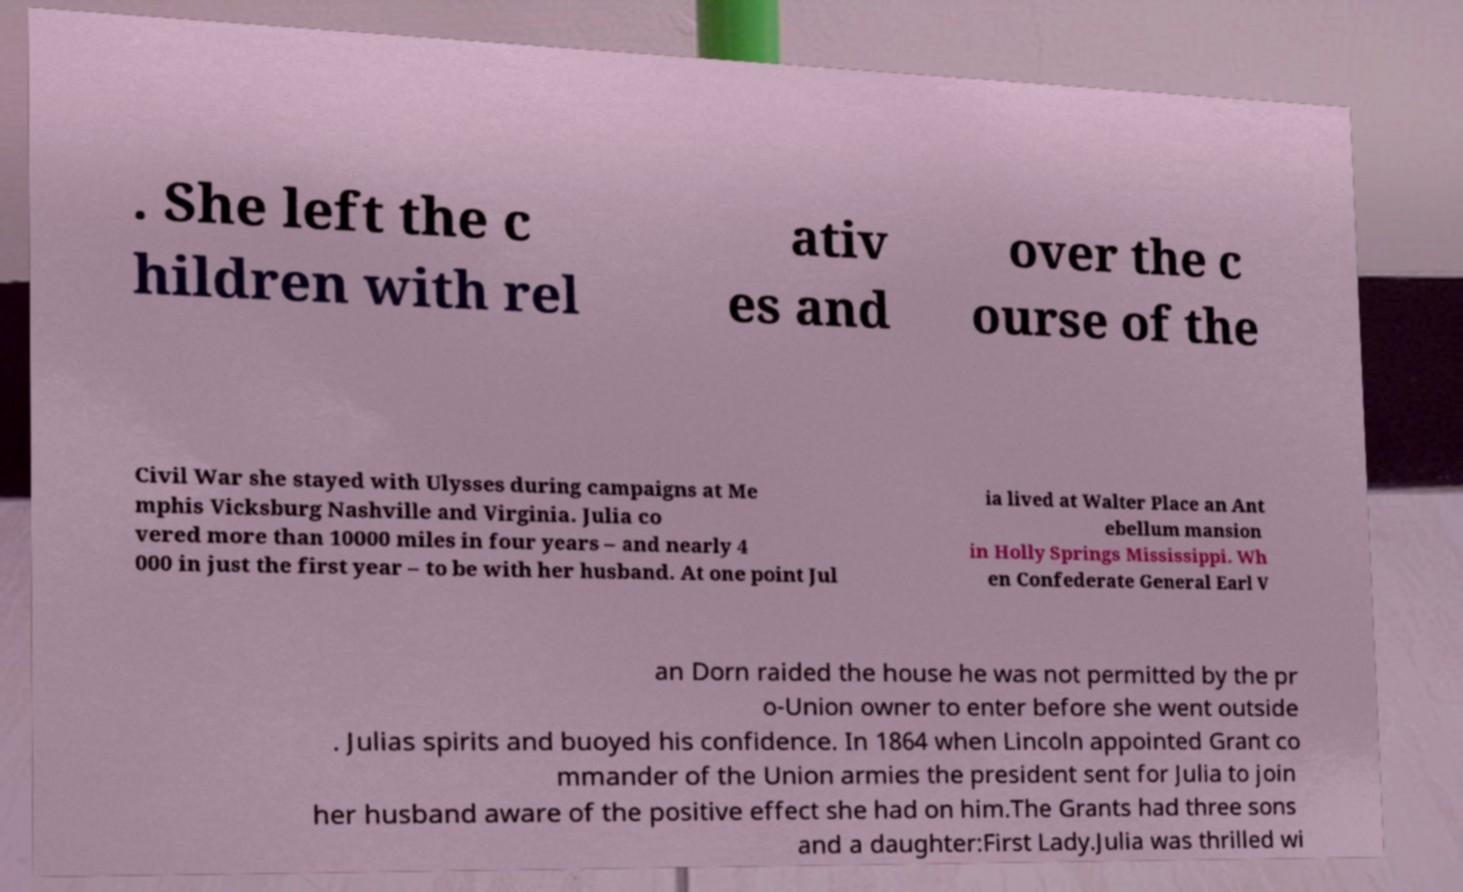I need the written content from this picture converted into text. Can you do that? . She left the c hildren with rel ativ es and over the c ourse of the Civil War she stayed with Ulysses during campaigns at Me mphis Vicksburg Nashville and Virginia. Julia co vered more than 10000 miles in four years – and nearly 4 000 in just the first year – to be with her husband. At one point Jul ia lived at Walter Place an Ant ebellum mansion in Holly Springs Mississippi. Wh en Confederate General Earl V an Dorn raided the house he was not permitted by the pr o-Union owner to enter before she went outside . Julias spirits and buoyed his confidence. In 1864 when Lincoln appointed Grant co mmander of the Union armies the president sent for Julia to join her husband aware of the positive effect she had on him.The Grants had three sons and a daughter:First Lady.Julia was thrilled wi 